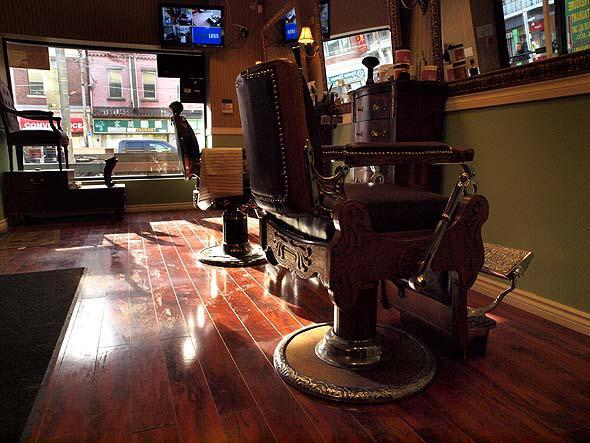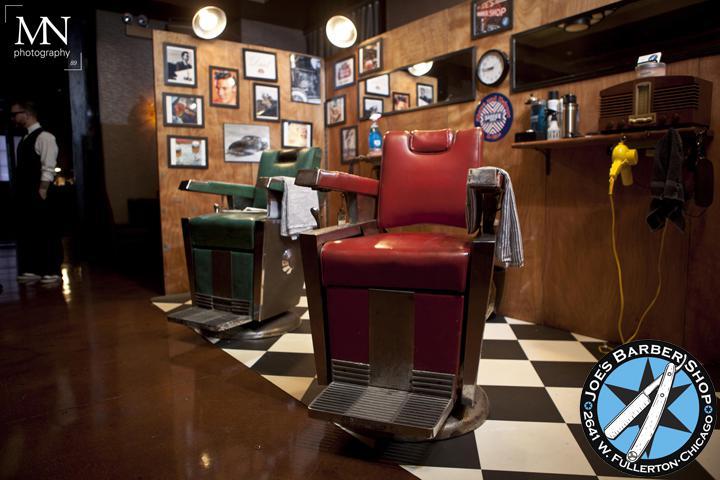The first image is the image on the left, the second image is the image on the right. Analyze the images presented: Is the assertion "One image shows a barber shop with a black and white checkerboard floor." valid? Answer yes or no. Yes. The first image is the image on the left, the second image is the image on the right. For the images displayed, is the sentence "There are exactly two barber chairs in the image on the right." factually correct? Answer yes or no. Yes. 